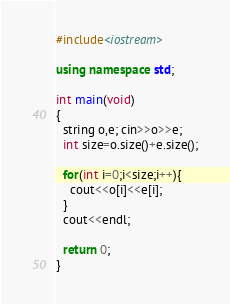Convert code to text. <code><loc_0><loc_0><loc_500><loc_500><_C++_>#include<iostream>

using namespace std;

int main(void)
{
  string o,e; cin>>o>>e;
  int size=o.size()+e.size();

  for(int i=0;i<size;i++){
    cout<<o[i]<<e[i];
  }
  cout<<endl;
  
  return 0;
}</code> 